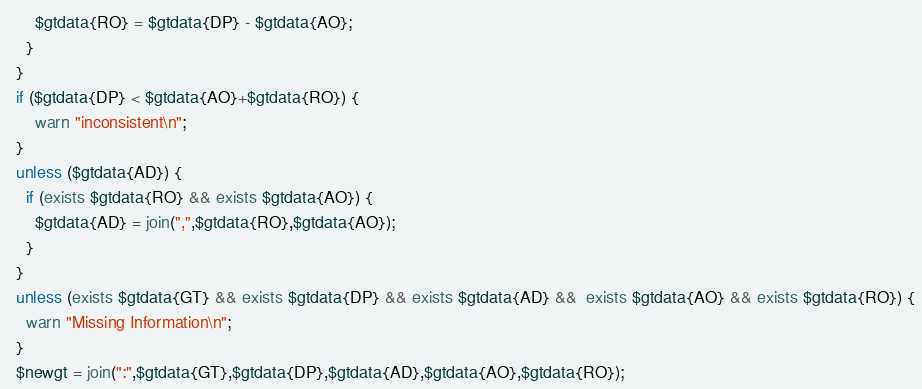<code> <loc_0><loc_0><loc_500><loc_500><_Perl_>      $gtdata{RO} = $gtdata{DP} - $gtdata{AO};
    }
  }
  if ($gtdata{DP} < $gtdata{AO}+$gtdata{RO}) {
      warn "inconsistent\n";
  }
  unless ($gtdata{AD}) {
    if (exists $gtdata{RO} && exists $gtdata{AO}) {
      $gtdata{AD} = join(",",$gtdata{RO},$gtdata{AO});
    }
  }
  unless (exists $gtdata{GT} && exists $gtdata{DP} && exists $gtdata{AD} &&  exists $gtdata{AO} && exists $gtdata{RO}) {
    warn "Missing Information\n";
  }
  $newgt = join(":",$gtdata{GT},$gtdata{DP},$gtdata{AD},$gtdata{AO},$gtdata{RO});</code> 